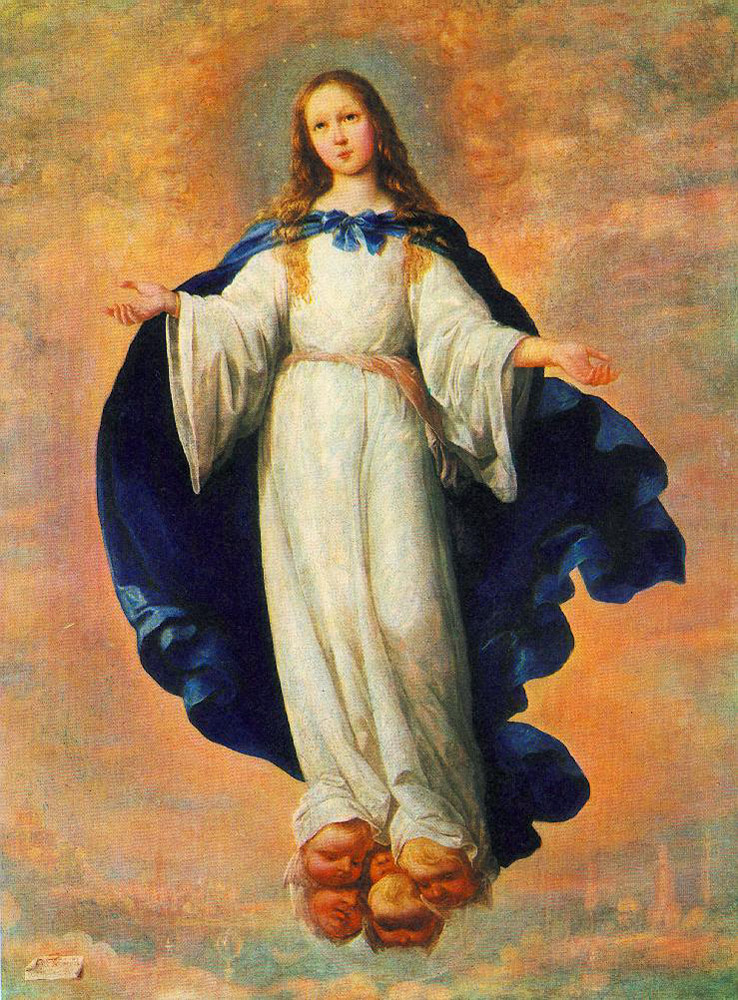Tell me a story about this scene. In a time long forgotten, in a land where the boundaries between the heavens and the earth were thin, there was a city blessed by the divine presence. High above this city, an ethereal figure known as Seraphina, Guardian of the Clouds, watched over its inhabitants. Seraphina was a young, celestial guardian with an aura that radiated purity and calm. She wore a white dress that shimmered like morning dew, and a blue cloak that carried the essence of the sky itself. Every dawn, she would come closer to the earth, blessing the city with golden light and soothing warmth.

One day, as the city lay under a veil of conflict and despair, the people looked up to the heavens for hope. It was then that Seraphina descended, her presence marked by a cascade of soft, glowing clouds. As she drew nearer, a hush fell over the city. People gathered, eyes wide with wonder, as they witnessed Seraphina’s descent. She touched down gently, her feet hovering inches above the ground, bringing with her an overwhelming sense of peace and compassion.

Seraphina's visit marked the beginning of change. Guided by her serene presence, the citizens found the courage to unite and overcome their adversity. They built monuments in her honor, and tales of her grace were recited in hushed, reverent tones for generations. And while she did not remain, her spirit lingered, ensuring that harmony and faith flourished within the city's walls. What is the importance of the blue cloak the figure is wearing? The blue cloak worn by the figure is likely of great significance. Blue often symbolizes tranquility, wisdom, and the vastness of the sky, which ties into the celestial and divine theme of the artwork. The cloak might represent the heavens, enveloping the figure in a divine aura and signifying her connection to the spiritual realm. It serves as a visual reminder of her ethereal nature and her protective oversight of the earthly realm below. What do you think the artist was trying to convey with this painting? The artist appears to be conveying a message of divine presence and serenity through this painting. The ethereal figure, suspended gracefully in the sky, symbolizes a divine guardian watching over the earthly realm below. The use of soft, radiant colors enhances the sense of calm and purity, suggesting themes of hope, guidance, and spiritual connection. The juxtaposition of the celestial being with the cityscape below may highlight the interplay between the divine and human worlds, emphasizing the notion of divine protection and inspiration amid the challenges of earthly life. What details stand out most to you in this painting? The details that stand out most include the serene expression of the figure, her graceful posture, and the meticulous rendering of her white dress and blue cloak. The cascading blonde hair and the way it catches the light adds to her ethereal quality. Additionally, the soft, glowing clouds and the subtle cityscape beneath her contribute to the painting’s depth and context, creating a seamless blend between the heavenly and earthly realms. Imagine Seraphina could speak to the people below. What might she say? “People of the city, I bring to you a message of hope and unity. In these times of strife, remember that you are not alone. The heavens have heard your pleas and now I descend to guide you towards light and peace. Embrace one another with compassion, look beyond your differences, and rebuild your bonds of community. In your hearts lies the strength to overcome any adversity. Let my presence be a reminder of the divine grace that surrounds and protects you always.” 